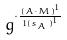<formula> <loc_0><loc_0><loc_500><loc_500>g ^ { \cdot \frac { ( A \cdot M ) ^ { 1 } } { 1 { ( s _ { A } ) } ^ { 1 } } }</formula> 